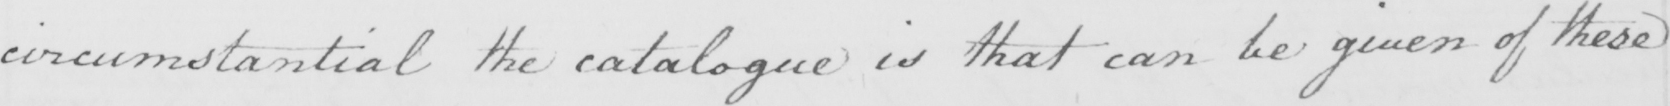What does this handwritten line say? circumstantial the catalogue is that can be given of these 